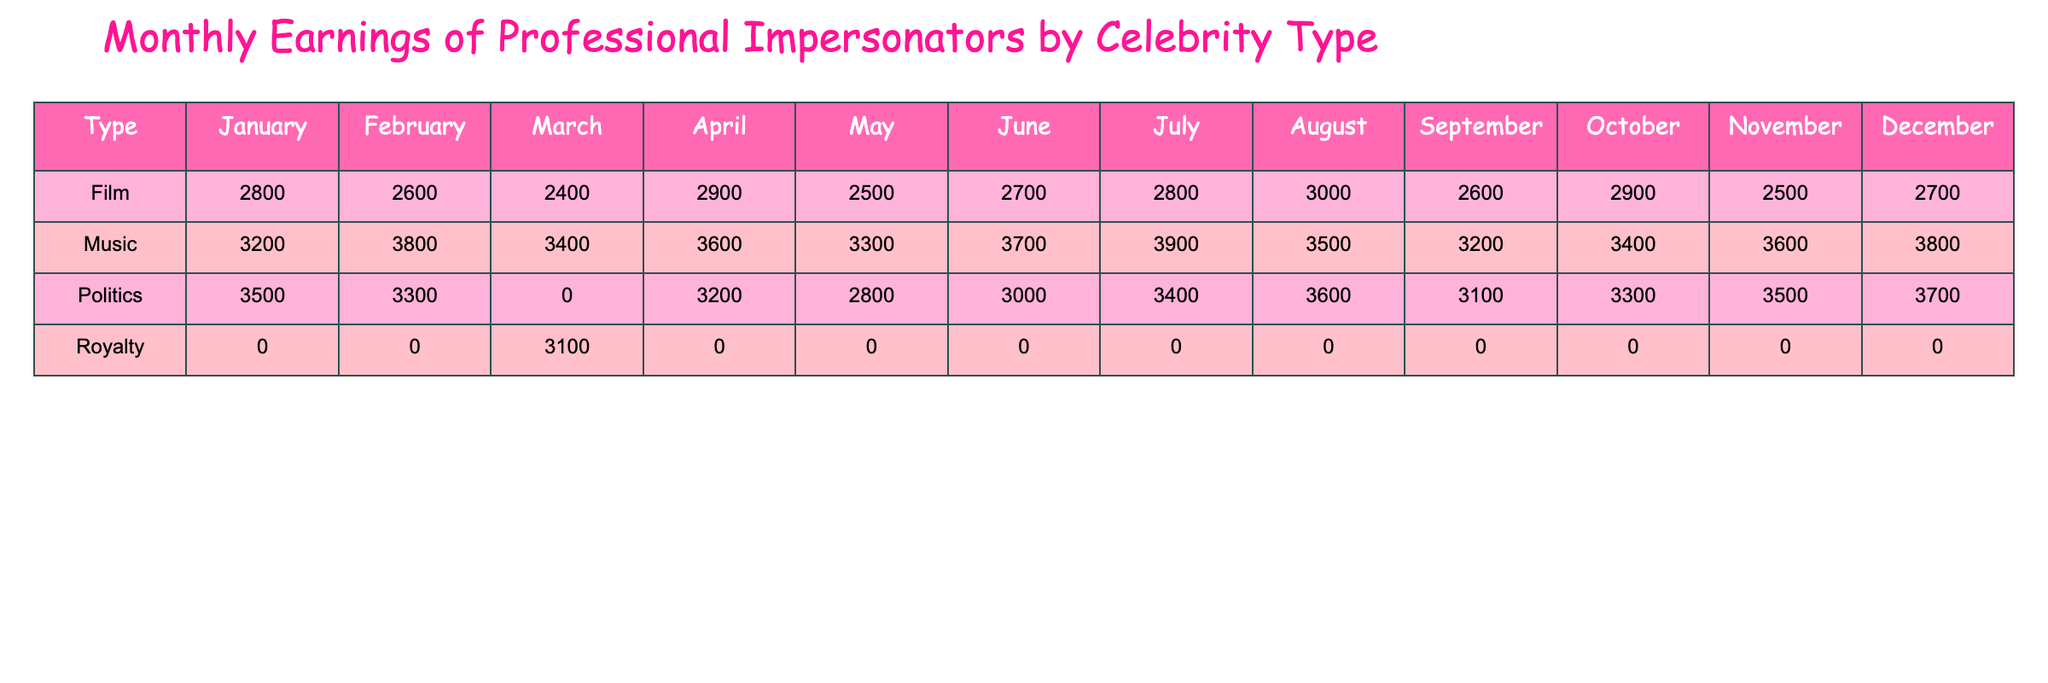What is the highest earning in July? Looking at the July column, the highest value under the earnings is 3900 from Beyoncé.
Answer: 3900 What type of celebrity earned the most in January? In January, the political celebrity Donald Trump earned the highest at 3500.
Answer: Politics What is the average earning for Film impersonators across all months? The Film earnings are: 2800, 2600, 2400, 2900, 2500, 2800, 2600, 2900, which totals to 23300. There are 9 entries, so dividing 23300 by 9 gives approximately 2588.89, which can be rounded to 2590.
Answer: 2590 Did any Music impersonators earn less than 3000 in August? In August, all Music impersonators, particularly Prince and the others, earned above 3000, specifically 3500, hence the answer is no.
Answer: No What is the difference between the total earnings of Politics and Music impersonators in March? In March, Politics earned a total of 3100; Music earnings summed up to 3400. The difference is calculated as 3400 - 3100 = 300.
Answer: 300 Which month saw the least earnings for Film impersonators? By examining each month's Film earnings, March has the least at 2400.
Answer: March Is it true that the earnings for Politics in September are lower than the earnings for Film in June? Politics in September earned 3100, while Film in June earned 2700. Since 3100 is not lower than 2700, this statement is false.
Answer: False What is the total earning across all Music impersonators? Summing all Music earnings: 3200 + 3800 + 3400 + 3600 + 3300 + 3700 + 3900 + 3500 + 3200 + 3400 + 3600 + 3800 gives a total of 39200.
Answer: 39200 